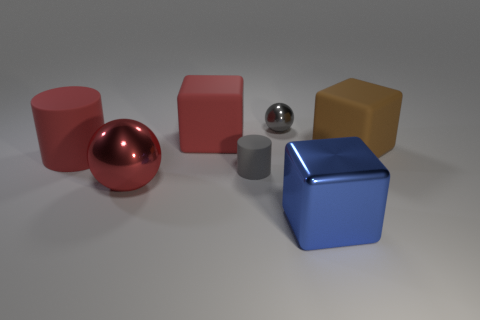Add 2 tiny cyan rubber cubes. How many objects exist? 9 Subtract all cubes. How many objects are left? 4 Subtract all small gray metallic things. Subtract all large brown blocks. How many objects are left? 5 Add 1 tiny shiny objects. How many tiny shiny objects are left? 2 Add 3 red cylinders. How many red cylinders exist? 4 Subtract 0 blue balls. How many objects are left? 7 